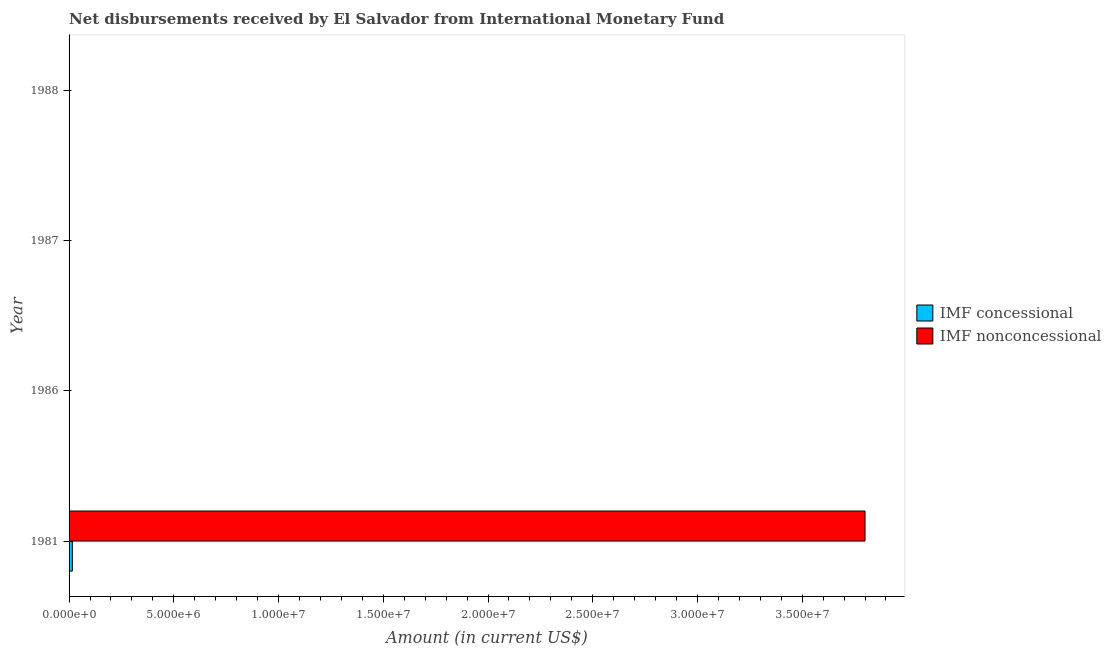Are the number of bars per tick equal to the number of legend labels?
Give a very brief answer. No. Are the number of bars on each tick of the Y-axis equal?
Your answer should be very brief. No. How many bars are there on the 1st tick from the top?
Your answer should be very brief. 0. Across all years, what is the maximum net non concessional disbursements from imf?
Provide a short and direct response. 3.80e+07. Across all years, what is the minimum net concessional disbursements from imf?
Make the answer very short. 0. In which year was the net concessional disbursements from imf maximum?
Make the answer very short. 1981. What is the total net concessional disbursements from imf in the graph?
Offer a terse response. 1.56e+05. What is the difference between the net non concessional disbursements from imf in 1981 and the net concessional disbursements from imf in 1988?
Your response must be concise. 3.80e+07. What is the average net non concessional disbursements from imf per year?
Your response must be concise. 9.50e+06. In the year 1981, what is the difference between the net concessional disbursements from imf and net non concessional disbursements from imf?
Provide a short and direct response. -3.78e+07. What is the difference between the highest and the lowest net non concessional disbursements from imf?
Offer a terse response. 3.80e+07. How many bars are there?
Keep it short and to the point. 2. Are all the bars in the graph horizontal?
Keep it short and to the point. Yes. Are the values on the major ticks of X-axis written in scientific E-notation?
Offer a very short reply. Yes. Does the graph contain grids?
Keep it short and to the point. No. Where does the legend appear in the graph?
Your response must be concise. Center right. How are the legend labels stacked?
Ensure brevity in your answer.  Vertical. What is the title of the graph?
Provide a short and direct response. Net disbursements received by El Salvador from International Monetary Fund. What is the label or title of the X-axis?
Your answer should be compact. Amount (in current US$). What is the Amount (in current US$) of IMF concessional in 1981?
Your answer should be compact. 1.56e+05. What is the Amount (in current US$) in IMF nonconcessional in 1981?
Give a very brief answer. 3.80e+07. What is the Amount (in current US$) in IMF concessional in 1986?
Make the answer very short. 0. What is the Amount (in current US$) of IMF concessional in 1987?
Provide a succinct answer. 0. What is the Amount (in current US$) of IMF concessional in 1988?
Your answer should be very brief. 0. Across all years, what is the maximum Amount (in current US$) in IMF concessional?
Offer a very short reply. 1.56e+05. Across all years, what is the maximum Amount (in current US$) of IMF nonconcessional?
Offer a terse response. 3.80e+07. Across all years, what is the minimum Amount (in current US$) in IMF nonconcessional?
Provide a succinct answer. 0. What is the total Amount (in current US$) of IMF concessional in the graph?
Make the answer very short. 1.56e+05. What is the total Amount (in current US$) in IMF nonconcessional in the graph?
Provide a short and direct response. 3.80e+07. What is the average Amount (in current US$) in IMF concessional per year?
Your response must be concise. 3.90e+04. What is the average Amount (in current US$) of IMF nonconcessional per year?
Your answer should be very brief. 9.50e+06. In the year 1981, what is the difference between the Amount (in current US$) in IMF concessional and Amount (in current US$) in IMF nonconcessional?
Provide a short and direct response. -3.78e+07. What is the difference between the highest and the lowest Amount (in current US$) in IMF concessional?
Provide a short and direct response. 1.56e+05. What is the difference between the highest and the lowest Amount (in current US$) in IMF nonconcessional?
Ensure brevity in your answer.  3.80e+07. 